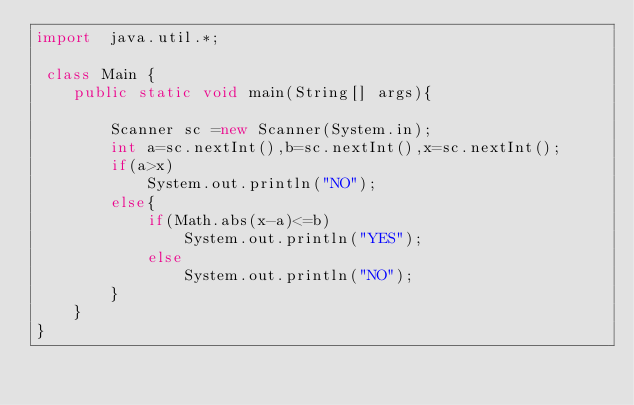<code> <loc_0><loc_0><loc_500><loc_500><_Java_>import  java.util.*;

 class Main {
    public static void main(String[] args){
        
        Scanner sc =new Scanner(System.in);
        int a=sc.nextInt(),b=sc.nextInt(),x=sc.nextInt();
        if(a>x)
            System.out.println("NO");
        else{
            if(Math.abs(x-a)<=b)
                System.out.println("YES");
            else
                System.out.println("NO");
        }
    }
}
</code> 